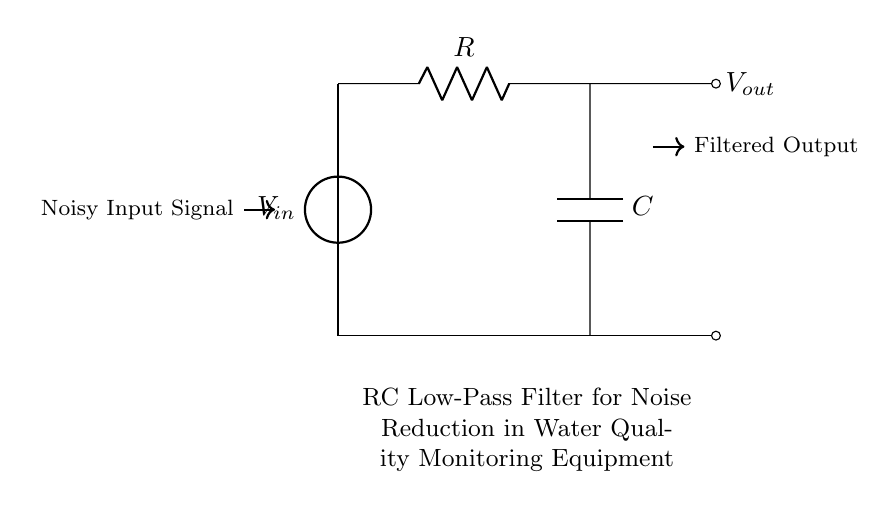What is the type of filter represented in the circuit? The circuit shows an RC low-pass filter, indicated by the arrangement of the resistor and capacitor that allows low-frequency signals to pass while attenuating higher frequencies.
Answer: RC low-pass filter What is the purpose of the capacitor in this circuit? The capacitor stores charge and helps smooth out fluctuations in the input signal, thereby reducing noise. Its role is crucial in filtering undesirable high-frequency noise from the input signal.
Answer: Reduce noise What component is connected to the output? The output is connected to the capacitor, which represents the filtered signal. The positioning of the component at the output end indicates its role in delivering the final useful signal after filtering.
Answer: Capacitor How does the resistor affect the circuit's performance at different frequencies? The resistor, in conjunction with the capacitor, determines the cutoff frequency of the filter. A higher resistance would lead to a lower cutoff frequency, allowing fewer high-frequency signals to pass through the circuit.
Answer: Determines cutoff frequency What is the relationship between input and output signals in this RC filter? The output signal is a smoothed version of the input signal, with high-frequency noise attenuated. This relationship is characteristic of low-pass filters where the output follows the input in the low-frequency range but lags behind or decreases at higher frequencies.
Answer: Smoothed version 